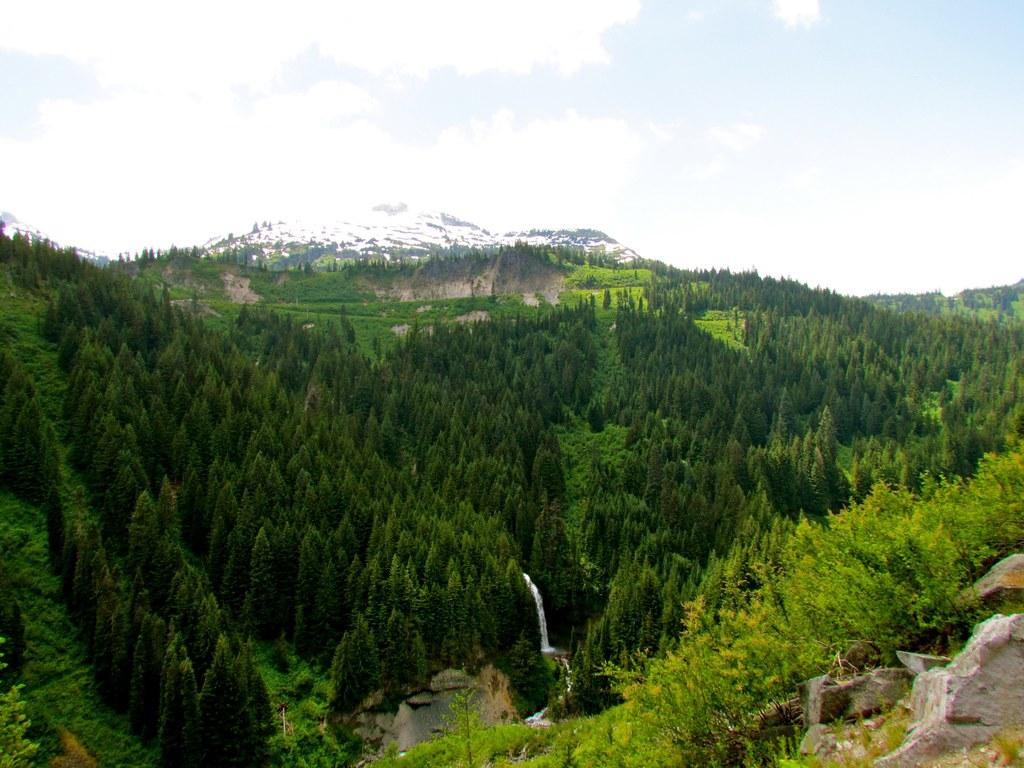What type of natural formation can be seen in the image? There are mountains in the image. What is growing on the mountains? There are trees on the mountains. What type of water feature is present in the image? There is a waterfall in the image. What can be seen in the background of the image? There are mountains and the sky visible in the background of the image. What type of jewel can be seen on the waterfall in the image? There are no jewels present on the waterfall in the image. How does the taste of the water in the waterfall compare to other water sources? The taste of the water in the waterfall cannot be determined from the image, as it does not provide any information about the water's taste. 